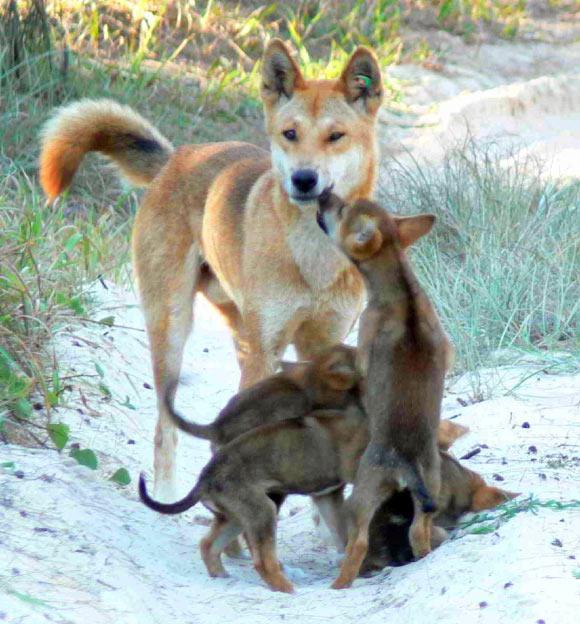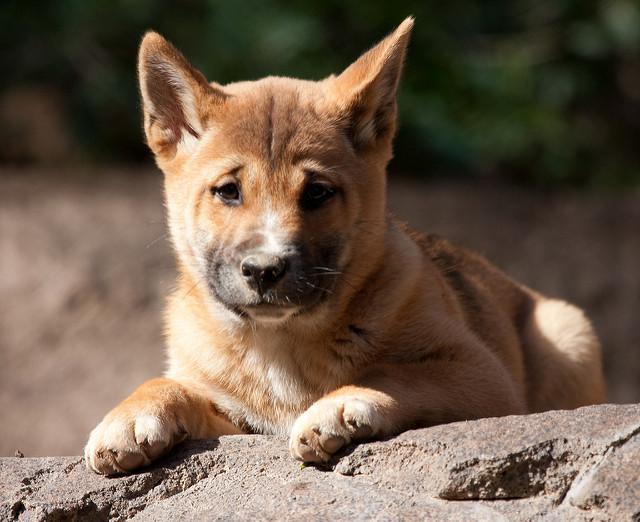The first image is the image on the left, the second image is the image on the right. Assess this claim about the two images: "Right image shows a canine looking directly into the camera.". Correct or not? Answer yes or no. Yes. The first image is the image on the left, the second image is the image on the right. For the images displayed, is the sentence "The animal in the image on the right is looking toward the camera" factually correct? Answer yes or no. Yes. 